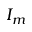<formula> <loc_0><loc_0><loc_500><loc_500>I _ { m }</formula> 